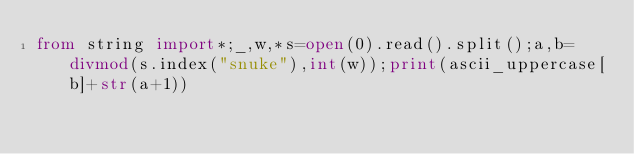<code> <loc_0><loc_0><loc_500><loc_500><_Python_>from string import*;_,w,*s=open(0).read().split();a,b=divmod(s.index("snuke"),int(w));print(ascii_uppercase[b]+str(a+1))</code> 